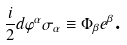<formula> <loc_0><loc_0><loc_500><loc_500>\frac { i } { 2 } d \varphi ^ { \alpha } \sigma _ { \alpha } \equiv \Phi _ { \beta } e ^ { \beta } \text {.}</formula> 